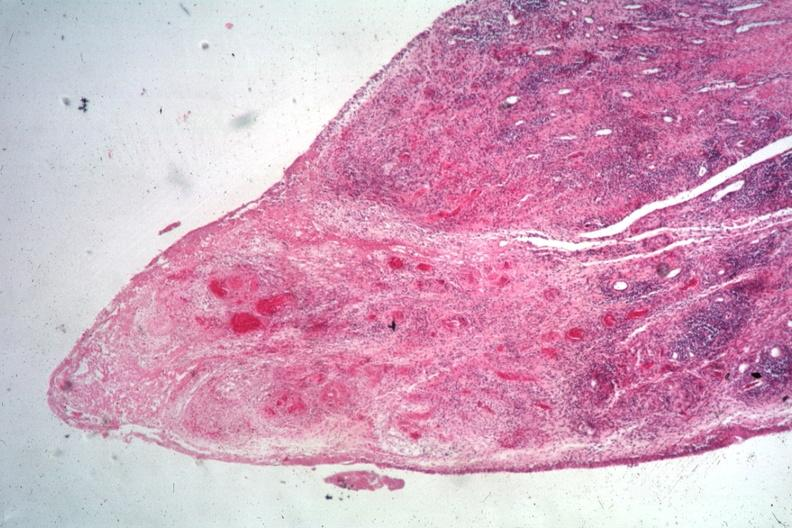what is present?
Answer the question using a single word or phrase. Joints 